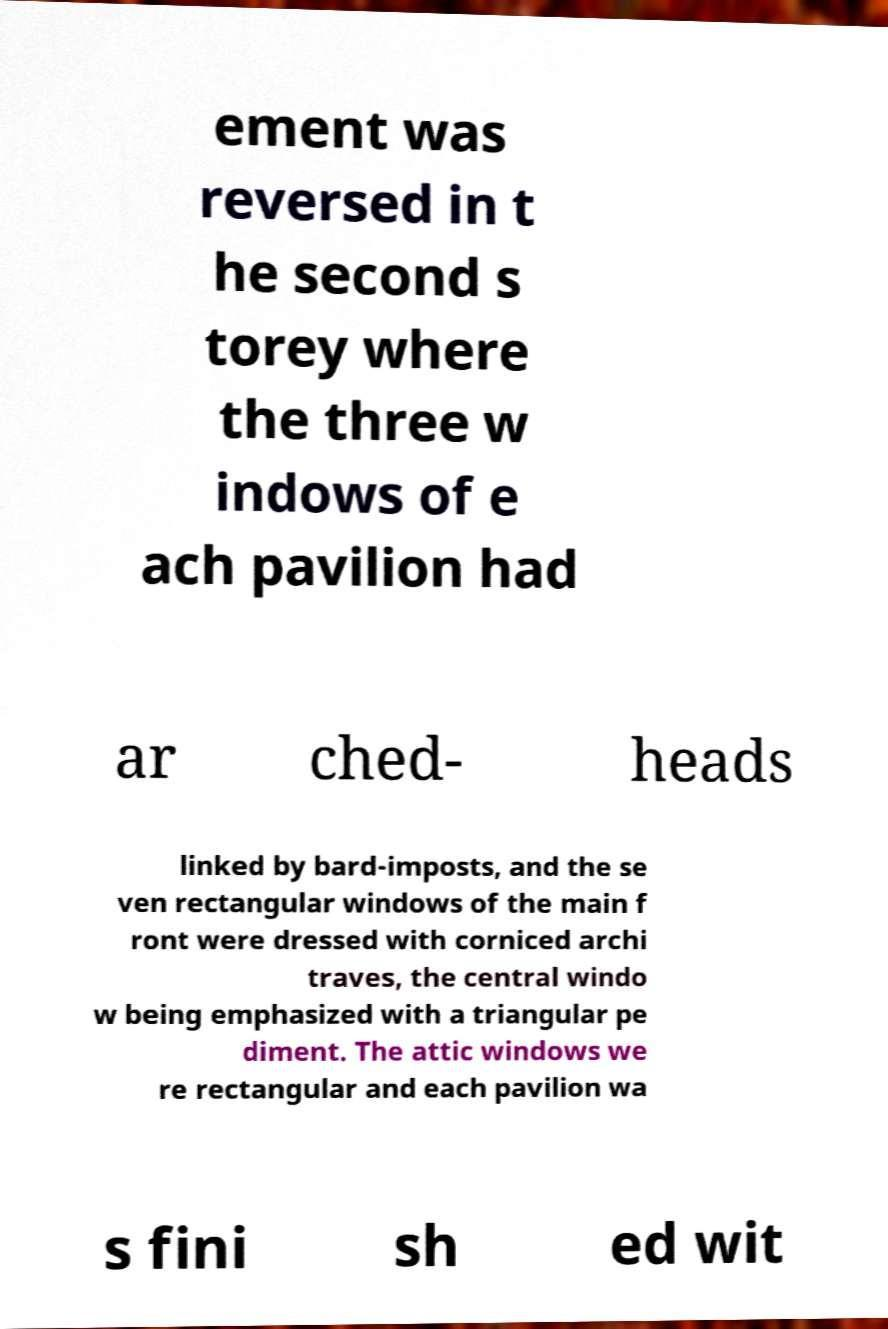I need the written content from this picture converted into text. Can you do that? ement was reversed in t he second s torey where the three w indows of e ach pavilion had ar ched- heads linked by bard-imposts, and the se ven rectangular windows of the main f ront were dressed with corniced archi traves, the central windo w being emphasized with a triangular pe diment. The attic windows we re rectangular and each pavilion wa s fini sh ed wit 